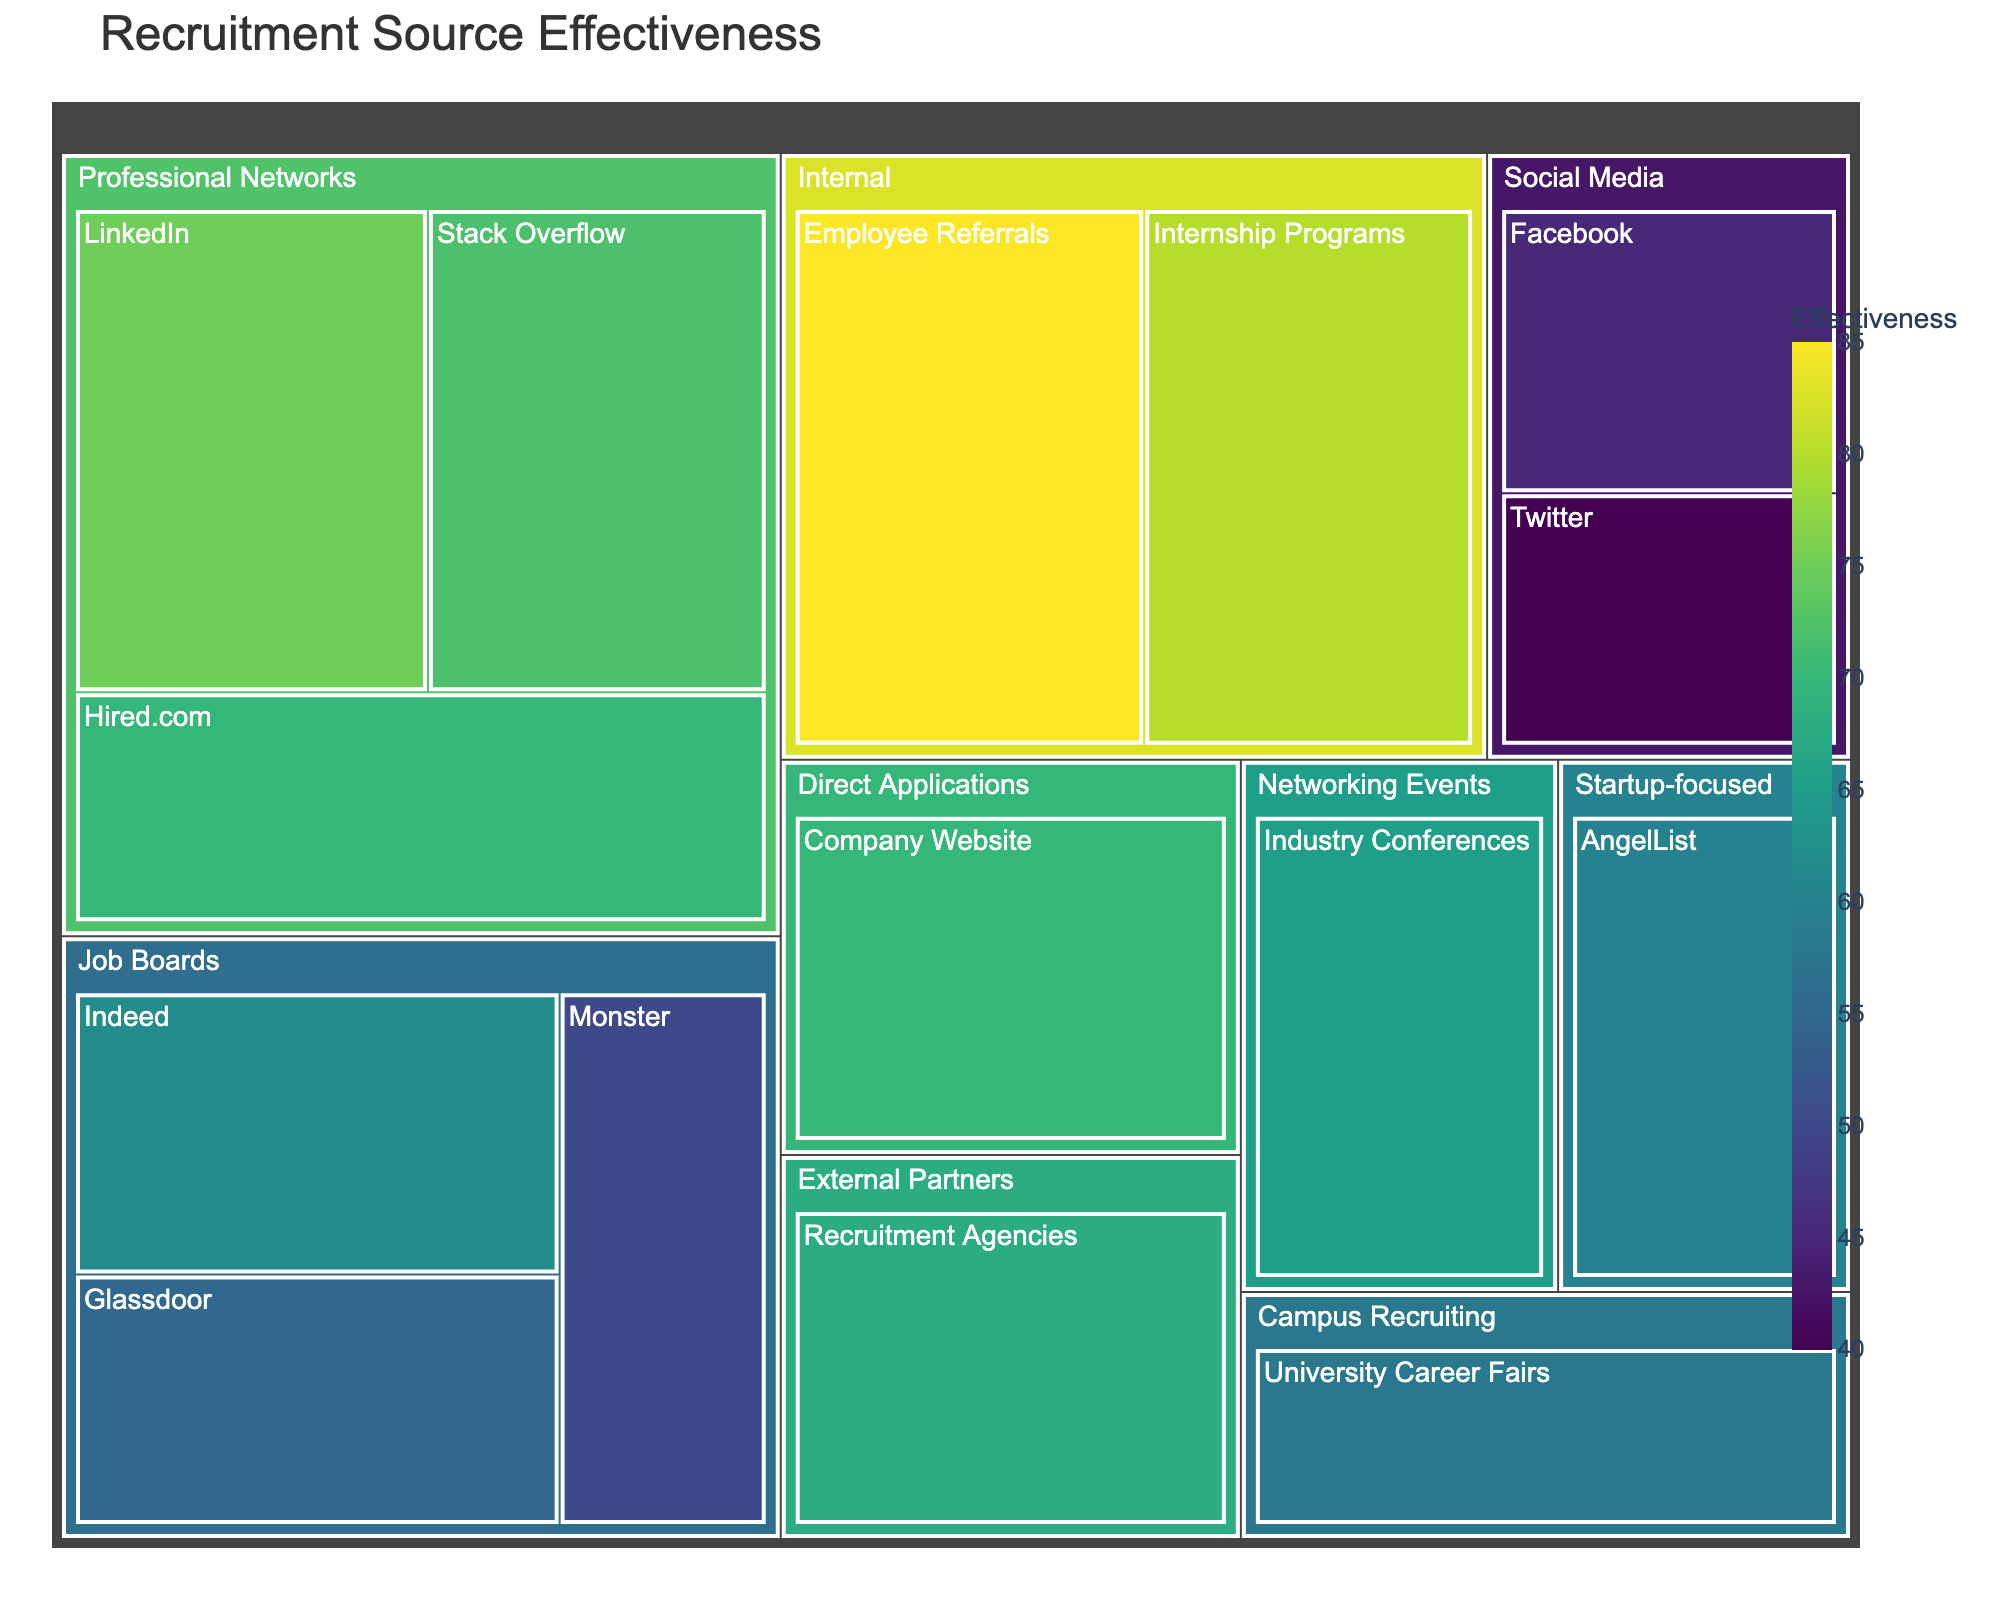Which recruitment source has the highest effectiveness? To find the answer, look for the source with the highest value in the effectiveness metric displayed in the treemap. Employee Referrals is the source with an effectiveness of 85.
Answer: Employee Referrals Which recruitment source from the Social Media category is the least effective? Find the Social Media category and within it, identify the source with the lowest effectiveness value. Twitter has the lowest effectiveness with a value of 40.
Answer: Twitter What's the total effectiveness of Job Boards category? Sum the effectiveness values of all the sources under the Job Boards category: Indeed (62), Glassdoor (55), and Monster (50). Total effectiveness is 62 + 55 + 50 = 167.
Answer: 167 Compare the effectiveness between LinkedIn and Company Website. Which one is higher? Look at the effectiveness values for LinkedIn (75) and Company Website (70). LinkedIn has a higher effectiveness value (75) than Company Website's (70).
Answer: LinkedIn What is the average effectiveness of the Internal category? Calculate the average effectiveness of sources within the Internal category: Employee Referrals (85) and Internship Programs (80). Average effectiveness = (85 + 80) / 2 = 82.5.
Answer: 82.5 Identify the least effective source in the Professional Networks category. Look within the Professional Networks category to find the source with the lowest effectiveness. Hired.com, LinkedIn, and Stack Overflow have effectiveness values of 70, 75, and 72 respectively. The least effective is Hired.com with 70.
Answer: Hired.com How does the effectiveness of Twitter compare to Facebook? Check the effectiveness values for Twitter (40) and Facebook (45). Facebook has a higher effectiveness value than Twitter.
Answer: Facebook What is the total effectiveness of Social Media and Networking Events categories combined? Add the effectiveness values for all sources in Social Media (Twitter: 40, Facebook: 45) and Networking Events (Industry Conferences: 65). Total effectiveness = (40 + 45) + 65 = 150.
Answer: 150 Which sources fall under the Campus Recruiting category and what are their effectiveness values? Locate the Campus Recruiting category in the treemap and identify the sources along with their effectiveness values. University Career Fairs has an effectiveness of 58.
Answer: University Career Fairs (58) 